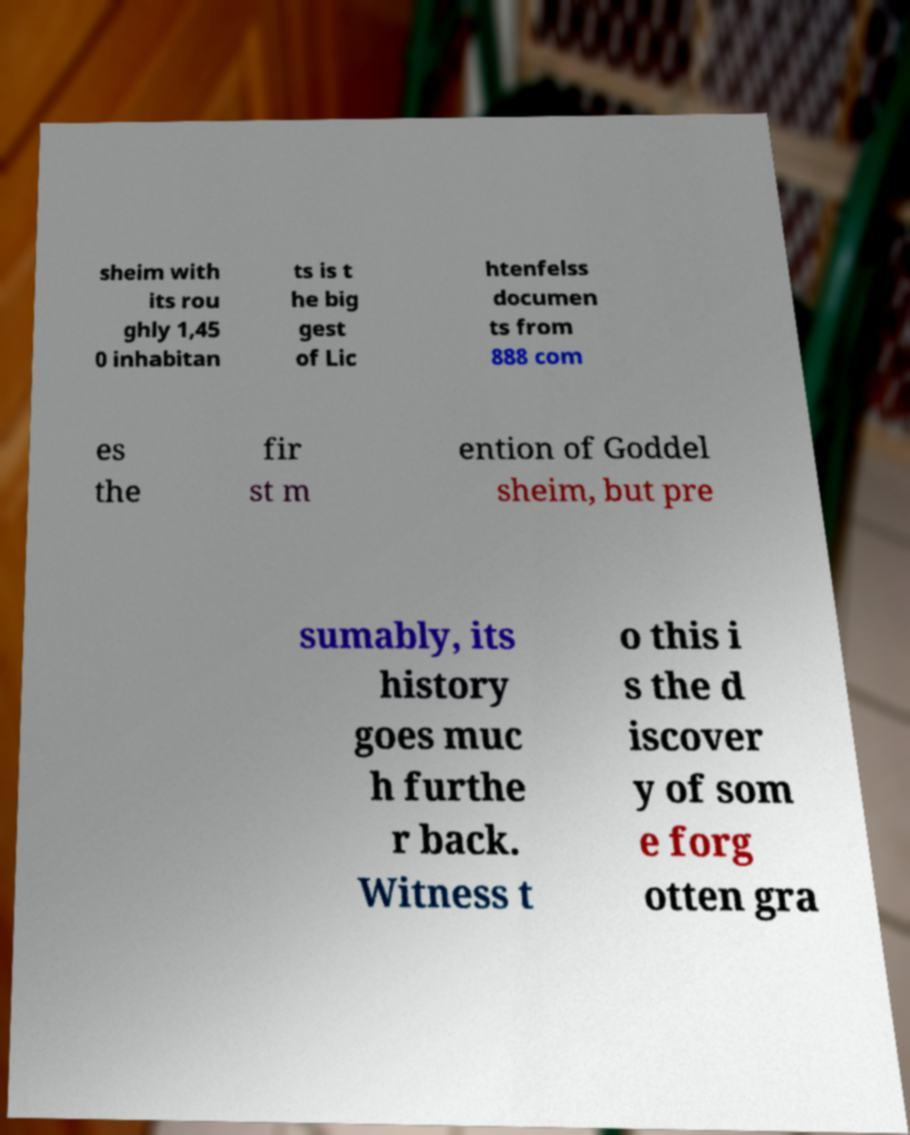Could you assist in decoding the text presented in this image and type it out clearly? sheim with its rou ghly 1,45 0 inhabitan ts is t he big gest of Lic htenfelss documen ts from 888 com es the fir st m ention of Goddel sheim, but pre sumably, its history goes muc h furthe r back. Witness t o this i s the d iscover y of som e forg otten gra 